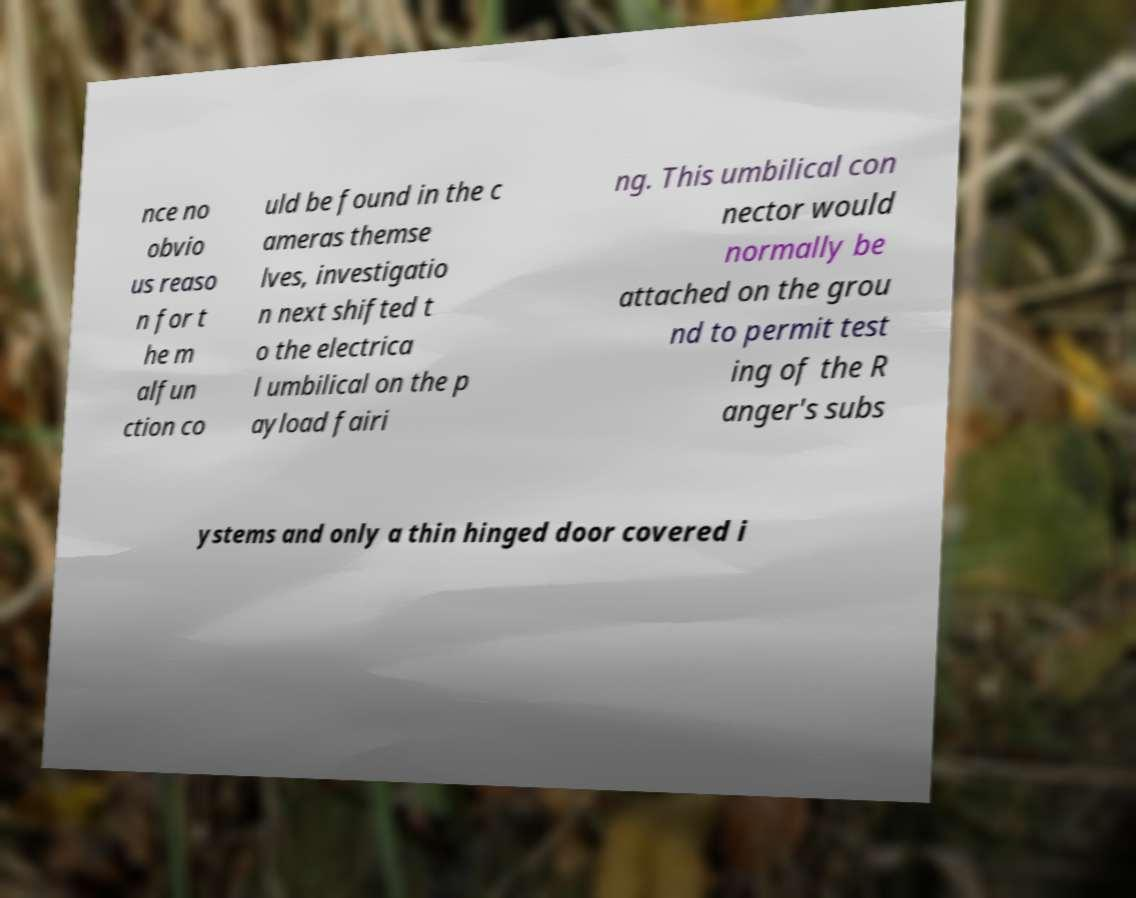Please read and relay the text visible in this image. What does it say? nce no obvio us reaso n for t he m alfun ction co uld be found in the c ameras themse lves, investigatio n next shifted t o the electrica l umbilical on the p ayload fairi ng. This umbilical con nector would normally be attached on the grou nd to permit test ing of the R anger's subs ystems and only a thin hinged door covered i 